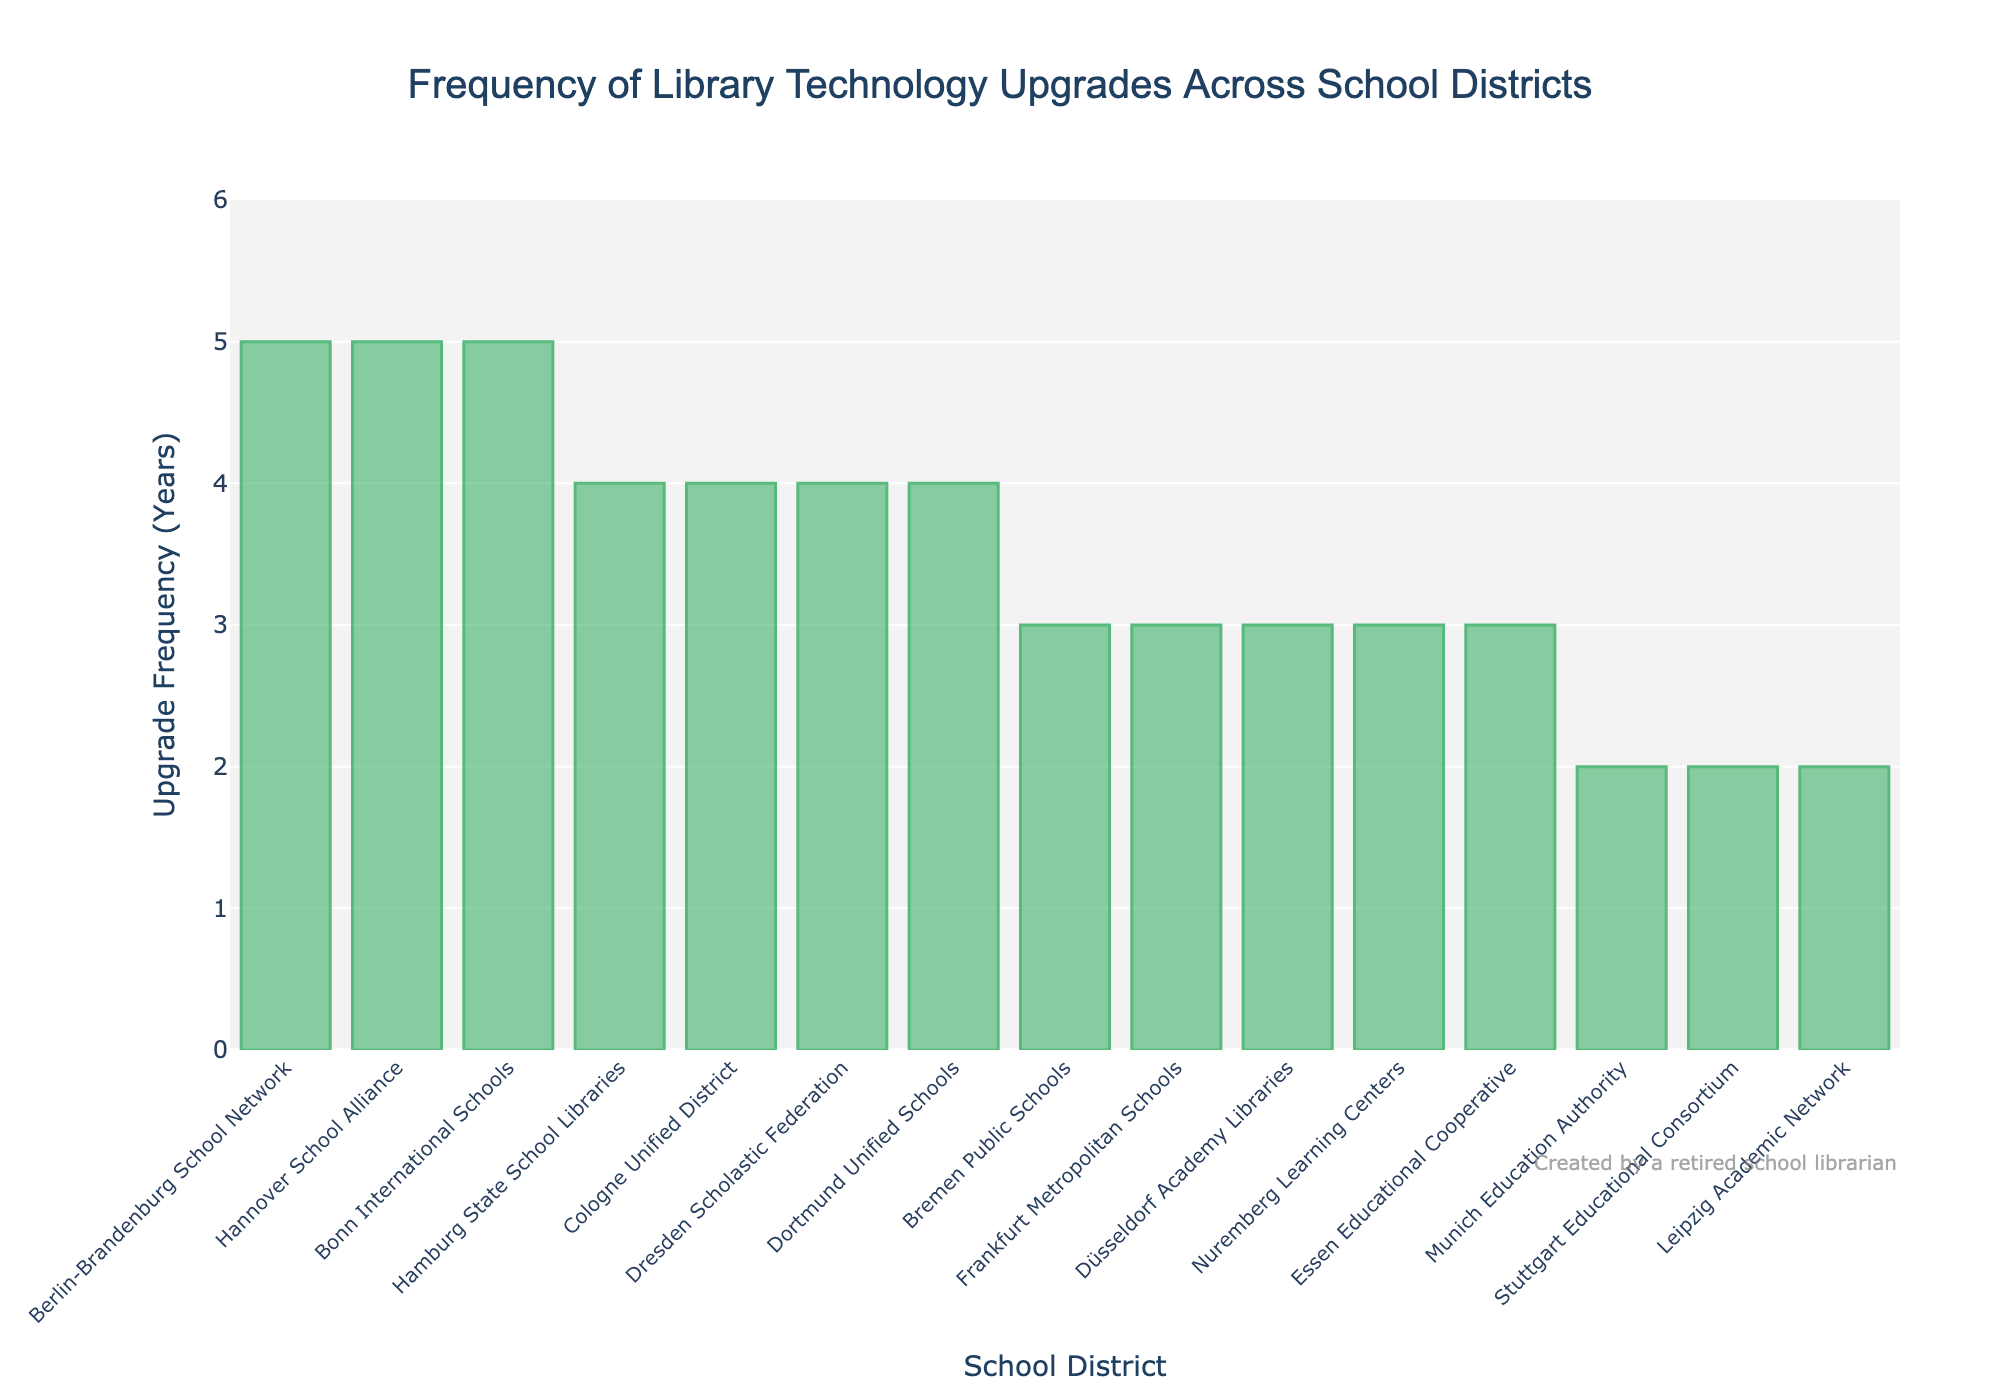Which school district has the longest frequency of library technology upgrades? By examining the bar chart, we can identify the tallest bar, representing 5 years. The school districts reaching this frequency include Berlin-Brandenburg School Network, Hannover School Alliance, and Bonn International Schools.
Answer: Berlin-Brandenburg School Network, Hannover School Alliance, Bonn International Schools Which school district upgrades its library technology most frequently? By observing the shortest bars in the chart, we can see that the Munich Education Authority, Stuttgart Educational Consortium, and Leipzig Academic Network all have the shortest bars, indicating a frequency of 2 years.
Answer: Munich Education Authority, Stuttgart Educational Consortium, Leipzig Academic Network How many school districts upgrade their library technology every 3 years? By counting the number of bars that reach the 3-year mark on the bar chart, we can see there are five such districts: Bremen Public Schools, Frankfurt Metropolitan Schools, Düsseldorf Academy Libraries, Nuremberg Learning Centers, and Essen Educational Cooperative.
Answer: 5 What's the average frequency of library technology upgrades across all school districts? Adding up all frequencies: 3 + 4 + 2 + 5 + 3 + 4 + 2 + 3 + 5 + 4 + 3 + 2 + 4 + 3 + 5 = 48 years. There are 15 school districts, so the average frequency is 48 / 15 = 3.2 years.
Answer: 3.2 years How does the frequency of technology upgrades for Hamburg State School Libraries compare to Essen Educational Cooperative? The bar for Hamburg State School Libraries reaches 4 years, while the bar for Essen Educational Cooperative reaches 3 years. This means Hamburg State School Libraries upgrade less frequently than Essen Educational Cooperative.
Answer: Hamburg State School Libraries less frequent Which school districts have the same frequency for upgrading their library technology? Observing the heights of the bars, school districts that share the same upgrade frequency are: 
- 2 years: Munich Education Authority, Stuttgart Educational Consortium, Leipzig Academic Network 
- 3 years: Bremen Public Schools, Frankfurt Metropolitan Schools, Düsseldorf Academy Libraries, Nuremberg Learning Centers, Essen Educational Cooperative
- 4 years: Hamburg State School Libraries, Cologne Unified District, Dresden Scholastic Federation, Dortmund Unified Schools 
- 5 years: Berlin-Brandenburg School Network, Hannover School Alliance, Bonn International Schools.
Answer: Multiple pairs with same frequency What is the difference in the upgrade frequency between the most frequent and the least frequent school districts? The most frequent upgrade is 2 years and the least frequent is 5 years. The difference is 5 - 2 = 3 years.
Answer: 3 years How many years apart are the upgrade frequencies of Berlin-Brandenburg School Network and Cologne Unified District? Berlin-Brandenburg School Network has an upgrade frequency of 5 years, while Cologne Unified District has 4 years. The difference is 5 - 4 = 1 year.
Answer: 1 year What's the sum of all years of upgrade frequencies for the first five school districts listed alphabetically? Alphabetically, the first five districts are: Berlin-Brandenburg School Network (5), Bonn International Schools (5), Bremen Public Schools (3), Cologne Unified District (4), and Dortmund Unified Schools (4). Summing them up gives 5 + 5 + 3 + 4 + 4 = 21 years.
Answer: 21 years 